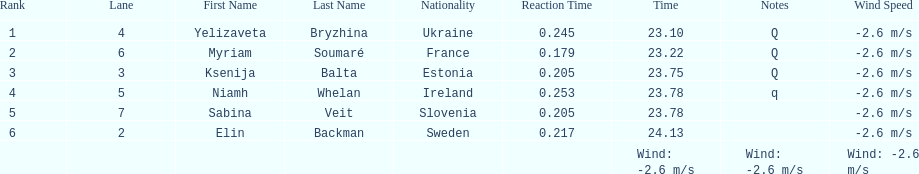Who finished after sabina veit? Elin Backman. 